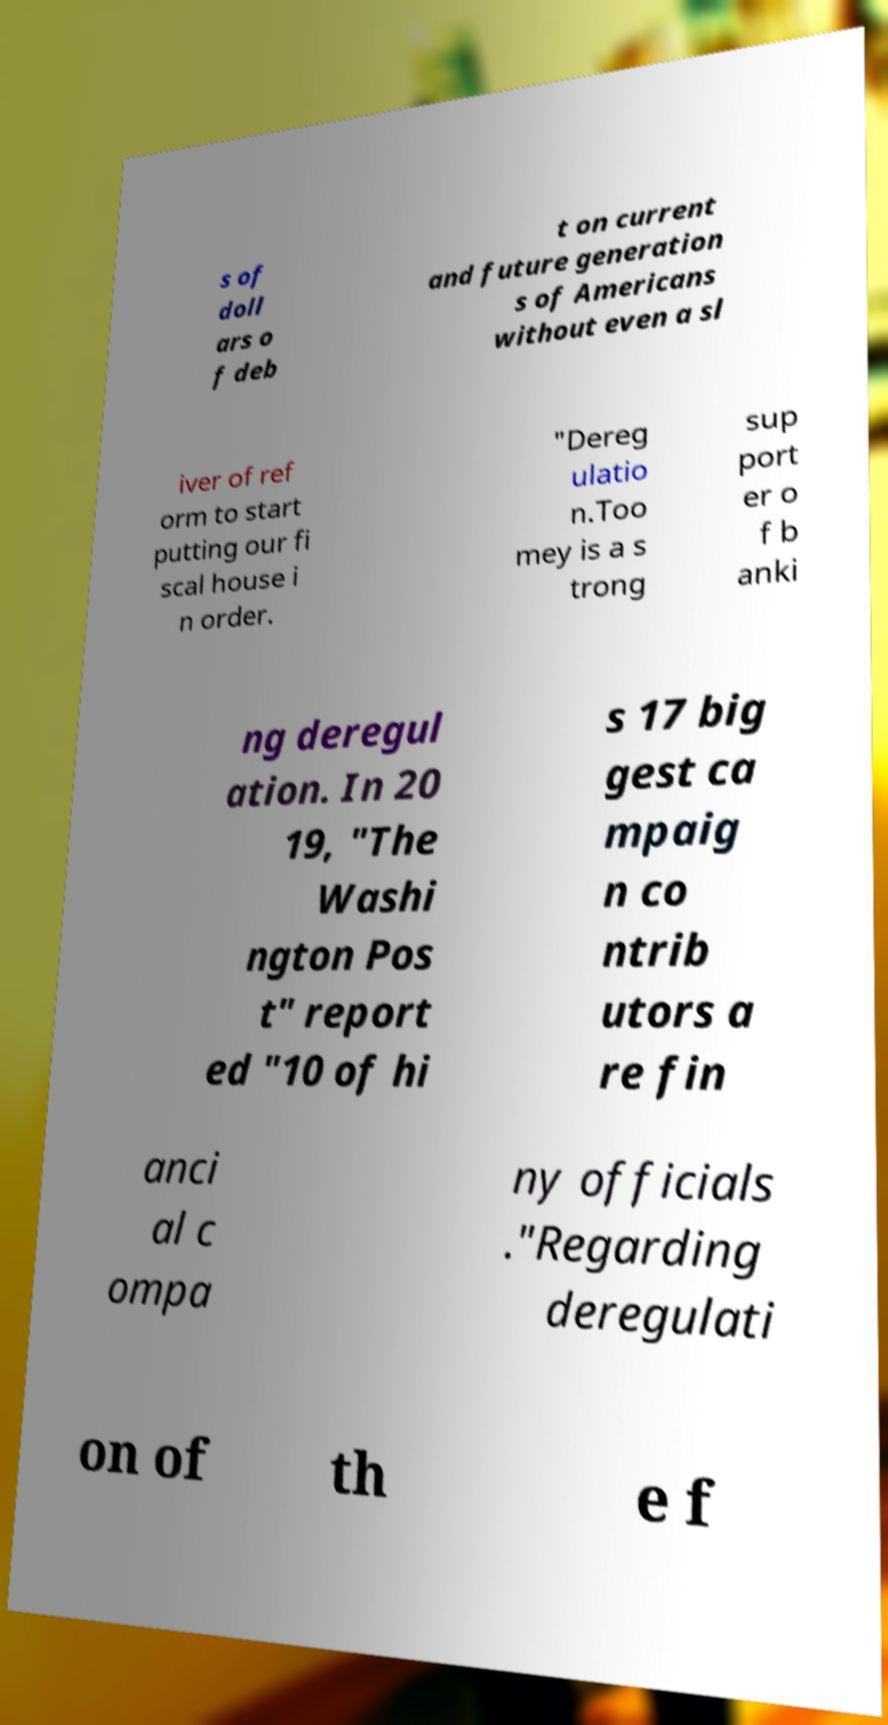I need the written content from this picture converted into text. Can you do that? s of doll ars o f deb t on current and future generation s of Americans without even a sl iver of ref orm to start putting our fi scal house i n order. "Dereg ulatio n.Too mey is a s trong sup port er o f b anki ng deregul ation. In 20 19, "The Washi ngton Pos t" report ed "10 of hi s 17 big gest ca mpaig n co ntrib utors a re fin anci al c ompa ny officials ."Regarding deregulati on of th e f 